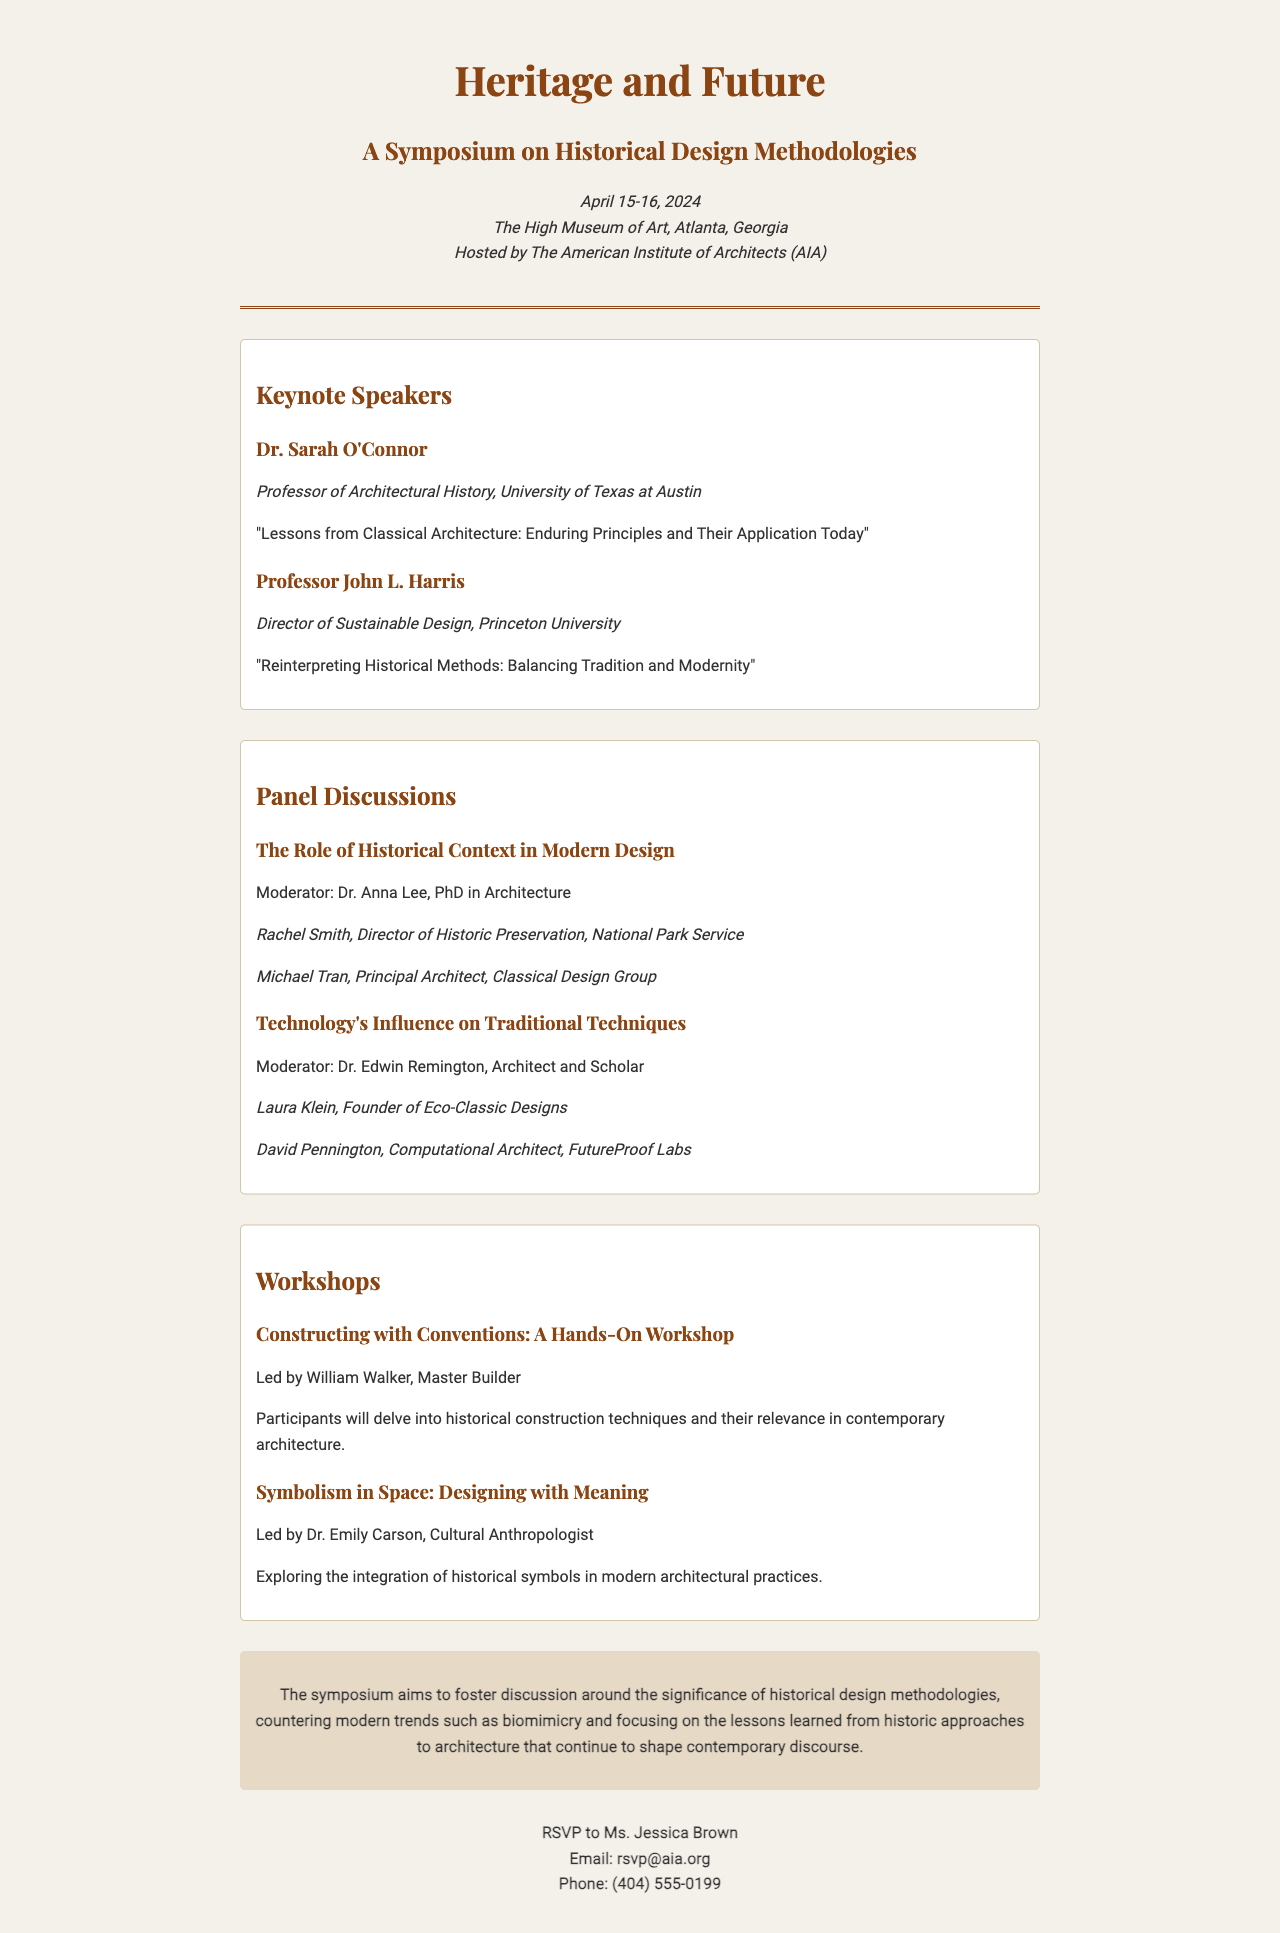What are the dates of the symposium? The symposium is scheduled for April 15-16, 2024, as indicated in the event details.
Answer: April 15-16, 2024 Who is the moderator for the panel on historical context? The document states that Dr. Anna Lee is moderating this particular panel discussion.
Answer: Dr. Anna Lee What is the title of Dr. Sarah O'Connor's keynote speech? Dr. Sarah O'Connor's keynote is titled "Lessons from Classical Architecture: Enduring Principles and Their Application Today."
Answer: Lessons from Classical Architecture: Enduring Principles and Their Application Today Which university is Professor John L. Harris affiliated with? The document mentions that he is the Director of Sustainable Design at Princeton University.
Answer: Princeton University What is the focus of the symposium according to the document? The document describes the symposium's focus as fostering discussion around the significance of historical design methodologies.
Answer: Historical design methodologies How many workshops are listed in the document? There are two workshops detailed in the section dedicated to workshops.
Answer: Two Who can be contacted for RSVPs? Ms. Jessica Brown is the contact person for RSVPs, as stated at the end of the document.
Answer: Ms. Jessica Brown What is the location of the symposium? The document specifies the symposium will take place at The High Museum of Art, Atlanta, Georgia.
Answer: The High Museum of Art, Atlanta, Georgia Which keynote speaker addresses sustainable design? Professor John L. Harris speaks about sustainable design in his keynote presentation.
Answer: Professor John L. Harris 